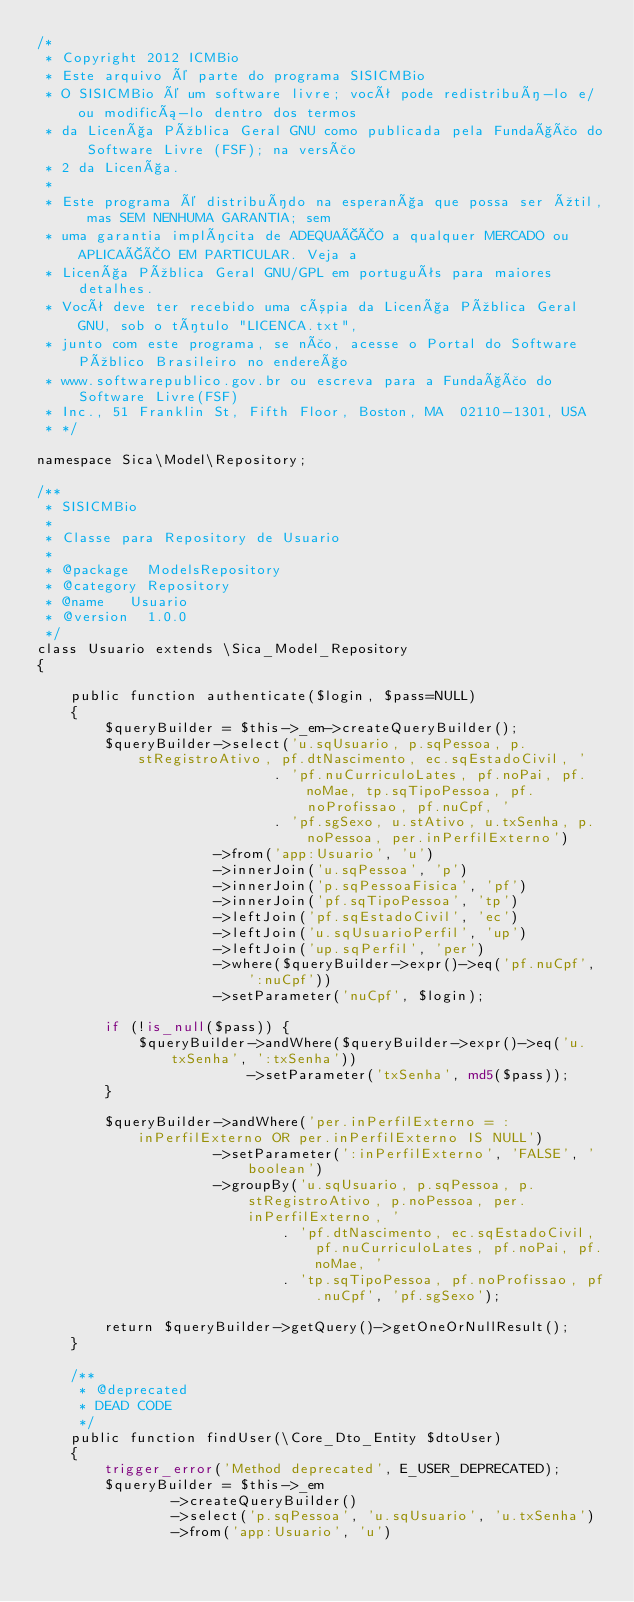Convert code to text. <code><loc_0><loc_0><loc_500><loc_500><_PHP_>/*
 * Copyright 2012 ICMBio
 * Este arquivo é parte do programa SISICMBio
 * O SISICMBio é um software livre; você pode redistribuí-lo e/ou modificá-lo dentro dos termos
 * da Licença Pública Geral GNU como publicada pela Fundação do Software Livre (FSF); na versão
 * 2 da Licença.
 *
 * Este programa é distribuído na esperança que possa ser útil, mas SEM NENHUMA GARANTIA; sem
 * uma garantia implícita de ADEQUAÇÃO a qualquer MERCADO ou APLICAÇÃO EM PARTICULAR. Veja a
 * Licença Pública Geral GNU/GPL em português para maiores detalhes.
 * Você deve ter recebido uma cópia da Licença Pública Geral GNU, sob o título "LICENCA.txt",
 * junto com este programa, se não, acesse o Portal do Software Público Brasileiro no endereço
 * www.softwarepublico.gov.br ou escreva para a Fundação do Software Livre(FSF)
 * Inc., 51 Franklin St, Fifth Floor, Boston, MA  02110-1301, USA
 * */

namespace Sica\Model\Repository;

/**
 * SISICMBio
 *
 * Classe para Repository de Usuario
 *
 * @package	 ModelsRepository
 * @category Repository
 * @name	 Usuario
 * @version	 1.0.0
 */
class Usuario extends \Sica_Model_Repository
{

    public function authenticate($login, $pass=NULL)
    {
        $queryBuilder = $this->_em->createQueryBuilder();
        $queryBuilder->select('u.sqUsuario, p.sqPessoa, p.stRegistroAtivo, pf.dtNascimento, ec.sqEstadoCivil, '
                            . 'pf.nuCurriculoLates, pf.noPai, pf.noMae, tp.sqTipoPessoa, pf.noProfissao, pf.nuCpf, '
                            . 'pf.sgSexo, u.stAtivo, u.txSenha, p.noPessoa, per.inPerfilExterno')
                     ->from('app:Usuario', 'u')
                     ->innerJoin('u.sqPessoa', 'p')
                     ->innerJoin('p.sqPessoaFisica', 'pf')
                     ->innerJoin('pf.sqTipoPessoa', 'tp')
                     ->leftJoin('pf.sqEstadoCivil', 'ec')
                     ->leftJoin('u.sqUsuarioPerfil', 'up')
                     ->leftJoin('up.sqPerfil', 'per')
                     ->where($queryBuilder->expr()->eq('pf.nuCpf', ':nuCpf'))
                     ->setParameter('nuCpf', $login);

        if (!is_null($pass)) {
            $queryBuilder->andWhere($queryBuilder->expr()->eq('u.txSenha', ':txSenha'))
                         ->setParameter('txSenha', md5($pass));
        }

        $queryBuilder->andWhere('per.inPerfilExterno = :inPerfilExterno OR per.inPerfilExterno IS NULL')
                     ->setParameter(':inPerfilExterno', 'FALSE', 'boolean')
                     ->groupBy('u.sqUsuario, p.sqPessoa, p.stRegistroAtivo, p.noPessoa, per.inPerfilExterno, '
                             . 'pf.dtNascimento, ec.sqEstadoCivil, pf.nuCurriculoLates, pf.noPai, pf.noMae, '
                             . 'tp.sqTipoPessoa, pf.noProfissao, pf.nuCpf', 'pf.sgSexo');

        return $queryBuilder->getQuery()->getOneOrNullResult();
    }

    /**
     * @deprecated
     * DEAD CODE
     */
    public function findUser(\Core_Dto_Entity $dtoUser)
    {
        trigger_error('Method deprecated', E_USER_DEPRECATED);
        $queryBuilder = $this->_em
                ->createQueryBuilder()
                ->select('p.sqPessoa', 'u.sqUsuario', 'u.txSenha')
                ->from('app:Usuario', 'u')</code> 